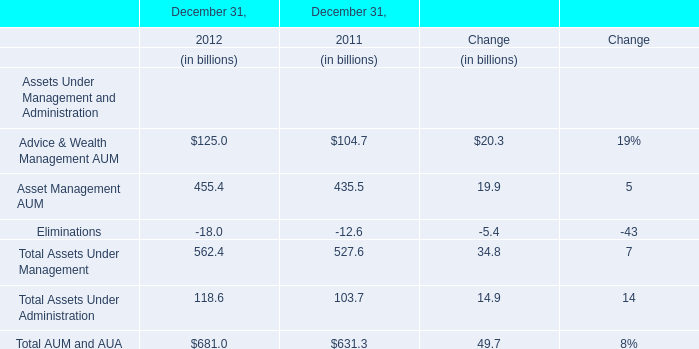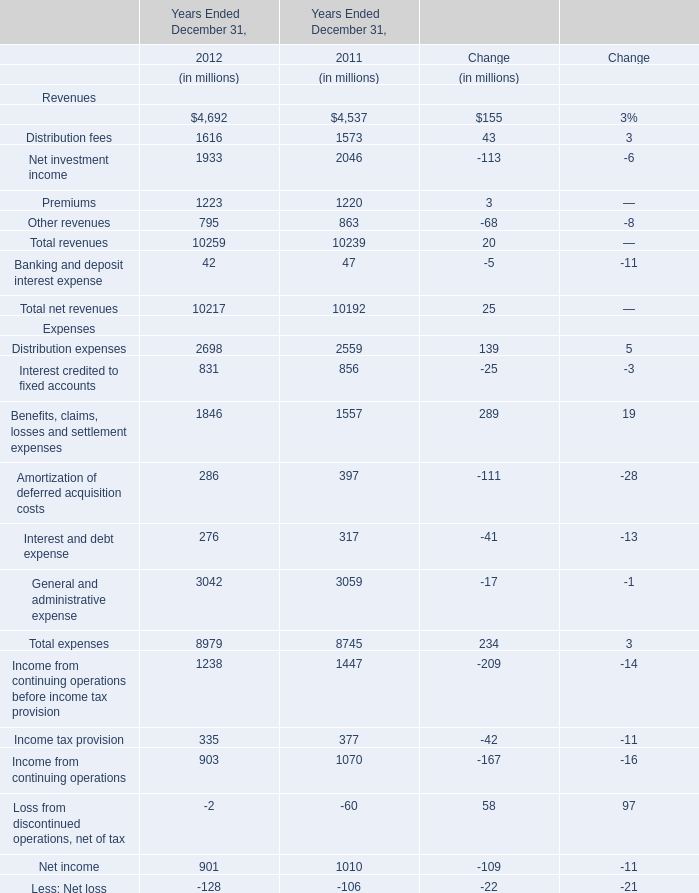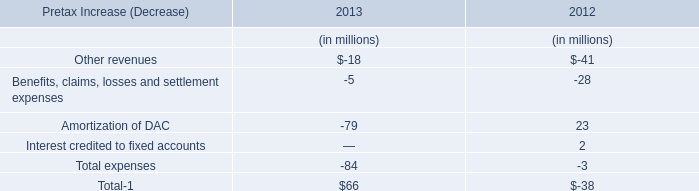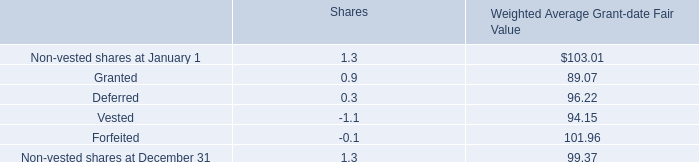What's the total amount of Assets Under Management excluding those Assets Under Management greater than 100 in 2012? (in billion) 
Computations: (125 + 455.4)
Answer: 580.4. 